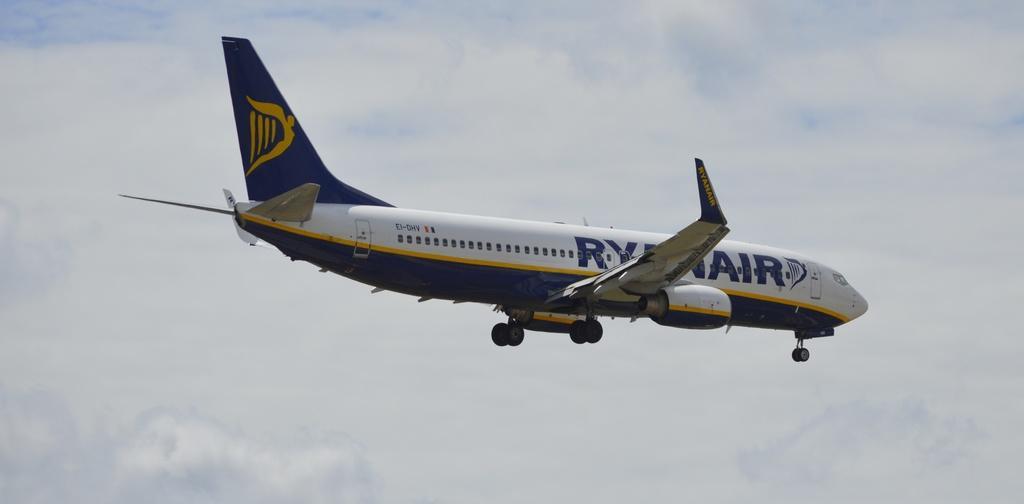How would you summarize this image in a sentence or two? In this image we can see a airplane in the sky. 